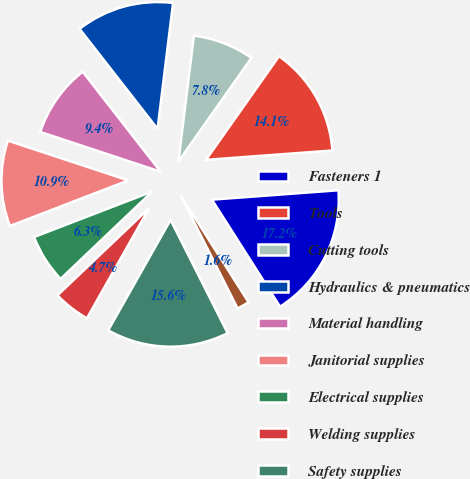Convert chart. <chart><loc_0><loc_0><loc_500><loc_500><pie_chart><fcel>Fasteners 1<fcel>Tools<fcel>Cutting tools<fcel>Hydraulics & pneumatics<fcel>Material handling<fcel>Janitorial supplies<fcel>Electrical supplies<fcel>Welding supplies<fcel>Safety supplies<fcel>Metals<nl><fcel>17.16%<fcel>14.05%<fcel>7.82%<fcel>12.49%<fcel>9.38%<fcel>10.93%<fcel>6.26%<fcel>4.71%<fcel>15.61%<fcel>1.59%<nl></chart> 